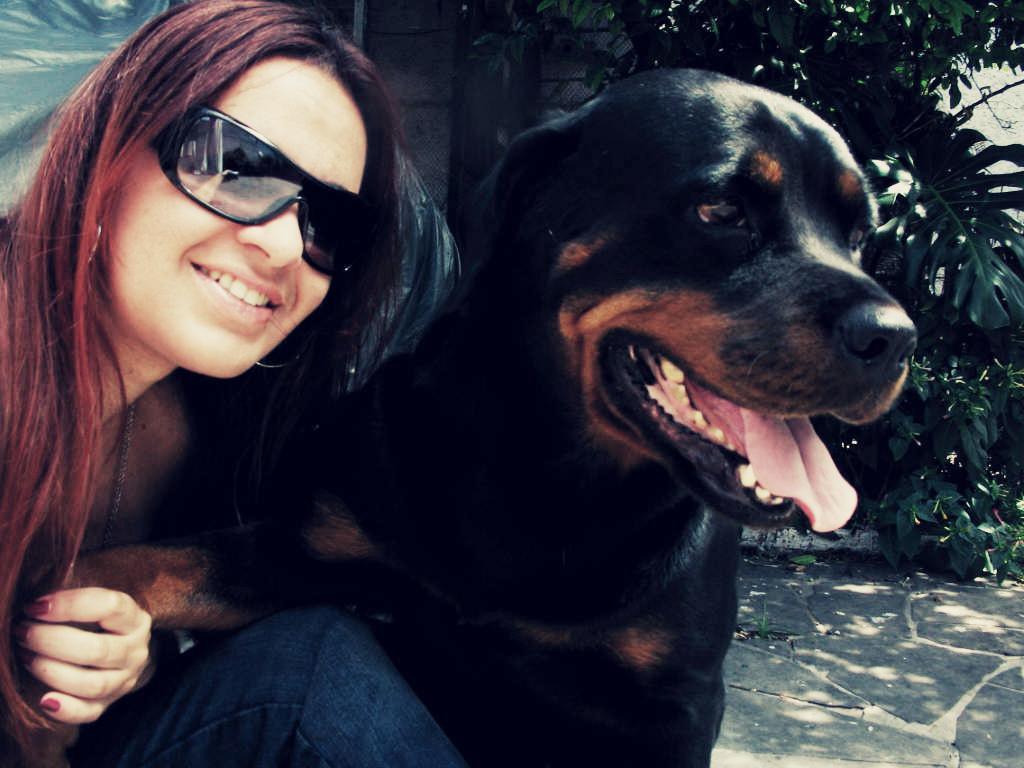Who is present in the image? There is a woman in the image. What is the woman doing in the image? The woman is sitting on the ground and smiling. What can be seen in the background of the image? There is a dog and a plant in the background of the image. What type of crime is being committed in the image? There is no crime being committed in the image; it features a woman sitting on the ground and smiling, with a dog and a plant in the background. 